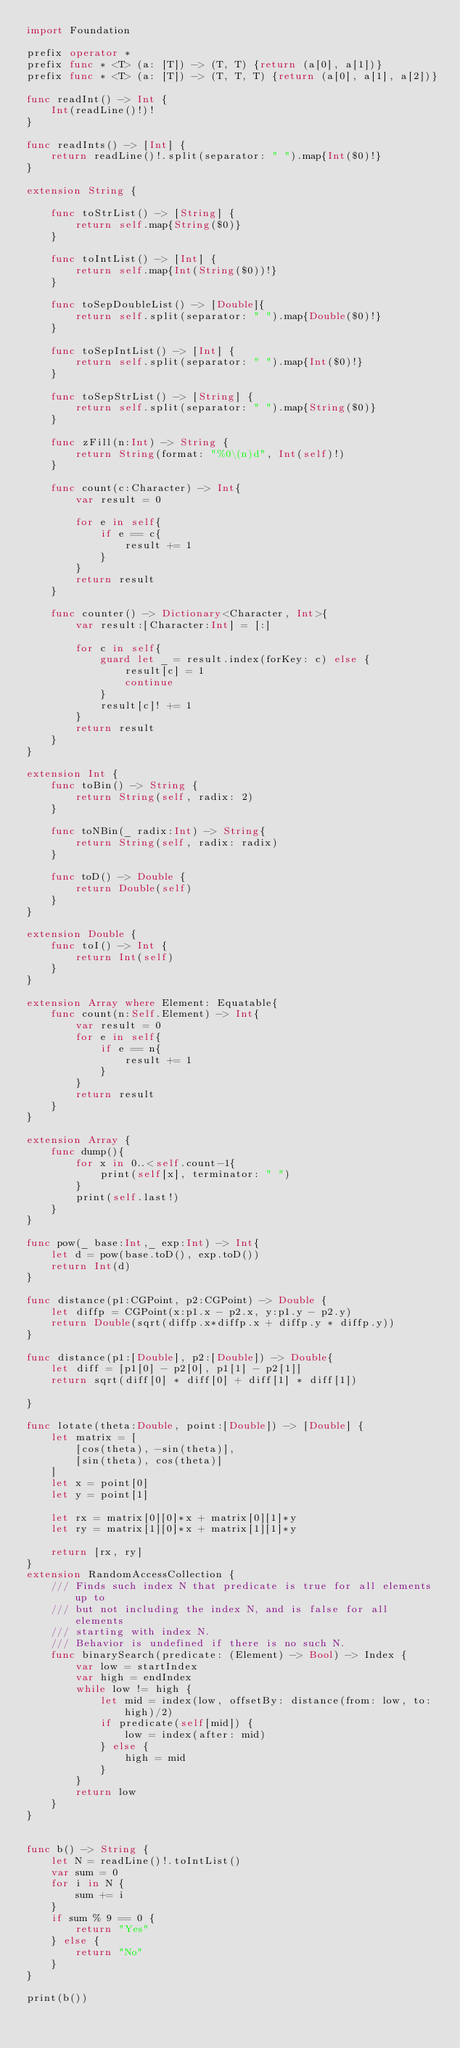<code> <loc_0><loc_0><loc_500><loc_500><_Swift_>import Foundation

prefix operator *
prefix func * <T> (a: [T]) -> (T, T) {return (a[0], a[1])}
prefix func * <T> (a: [T]) -> (T, T, T) {return (a[0], a[1], a[2])}

func readInt() -> Int {
    Int(readLine()!)!
}

func readInts() -> [Int] {
    return readLine()!.split(separator: " ").map{Int($0)!}
}

extension String {
    
    func toStrList() -> [String] {
        return self.map{String($0)}
    }
    
    func toIntList() -> [Int] {
        return self.map{Int(String($0))!}
    }
    
    func toSepDoubleList() -> [Double]{
        return self.split(separator: " ").map{Double($0)!}
    }

    func toSepIntList() -> [Int] {
        return self.split(separator: " ").map{Int($0)!}
    }

    func toSepStrList() -> [String] {
        return self.split(separator: " ").map{String($0)}
    }
    
    func zFill(n:Int) -> String {
        return String(format: "%0\(n)d", Int(self)!)
    }
    
    func count(c:Character) -> Int{
        var result = 0

        for e in self{
            if e == c{
                result += 1
            }
        }
        return result
    }

    func counter() -> Dictionary<Character, Int>{
        var result:[Character:Int] = [:]
        
        for c in self{
            guard let _ = result.index(forKey: c) else {
                result[c] = 1
                continue
            }
            result[c]! += 1
        }
        return result
    }
}

extension Int {
    func toBin() -> String {
        return String(self, radix: 2)
    }
    
    func toNBin(_ radix:Int) -> String{
        return String(self, radix: radix)
    }
    
    func toD() -> Double {
        return Double(self)
    }
}

extension Double {
    func toI() -> Int {
        return Int(self)
    }
}

extension Array where Element: Equatable{
    func count(n:Self.Element) -> Int{
        var result = 0
        for e in self{
            if e == n{
                result += 1
            }
        }
        return result
    }
}

extension Array {
    func dump(){
        for x in 0..<self.count-1{
            print(self[x], terminator: " ")
        }
        print(self.last!)
    }
}

func pow(_ base:Int,_ exp:Int) -> Int{
    let d = pow(base.toD(), exp.toD())
    return Int(d)
}

func distance(p1:CGPoint, p2:CGPoint) -> Double {
    let diffp = CGPoint(x:p1.x - p2.x, y:p1.y - p2.y)
    return Double(sqrt(diffp.x*diffp.x + diffp.y * diffp.y))
}

func distance(p1:[Double], p2:[Double]) -> Double{
    let diff = [p1[0] - p2[0], p1[1] - p2[1]]
    return sqrt(diff[0] * diff[0] + diff[1] * diff[1])
    
}

func lotate(theta:Double, point:[Double]) -> [Double] {
    let matrix = [
        [cos(theta), -sin(theta)],
        [sin(theta), cos(theta)]
    ]
    let x = point[0]
    let y = point[1]
    
    let rx = matrix[0][0]*x + matrix[0][1]*y
    let ry = matrix[1][0]*x + matrix[1][1]*y
    
    return [rx, ry]
}
extension RandomAccessCollection {
    /// Finds such index N that predicate is true for all elements up to
    /// but not including the index N, and is false for all elements
    /// starting with index N.
    /// Behavior is undefined if there is no such N.
    func binarySearch(predicate: (Element) -> Bool) -> Index {
        var low = startIndex
        var high = endIndex
        while low != high {
            let mid = index(low, offsetBy: distance(from: low, to: high)/2)
            if predicate(self[mid]) {
                low = index(after: mid)
            } else {
                high = mid
            }
        }
        return low
    }
}


func b() -> String {
    let N = readLine()!.toIntList()
    var sum = 0
    for i in N {
        sum += i
    }
    if sum % 9 == 0 {
        return "Yes"
    } else {
        return "No"
    }
}

print(b())
</code> 